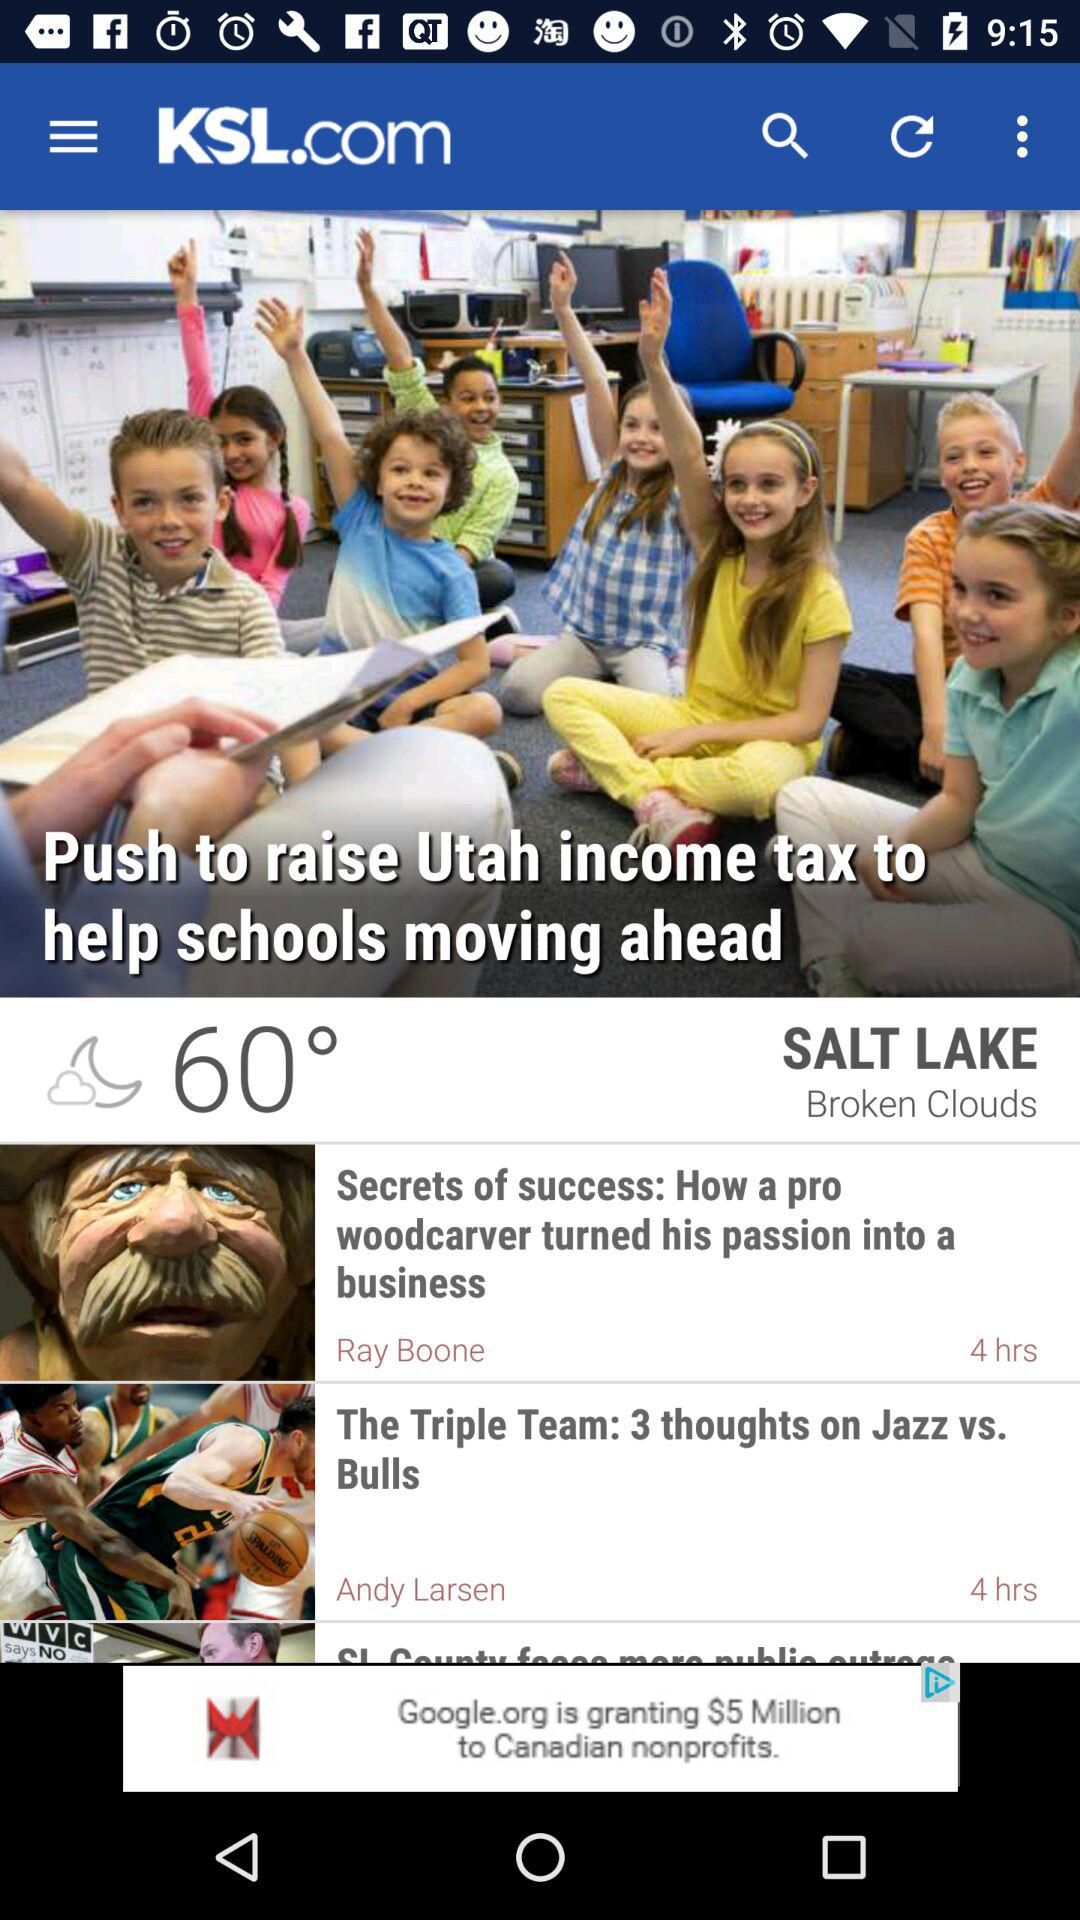Who is the author of "Secrets of success"? The author of "Secrets of success" is Ray Boone. 